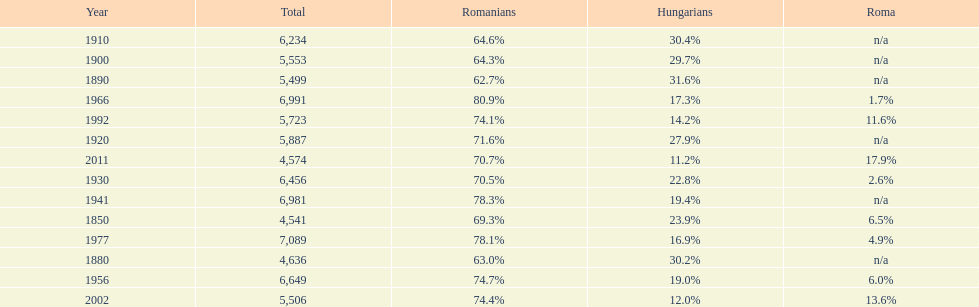Which year had a total of 6,981 and 19.4% hungarians? 1941. 